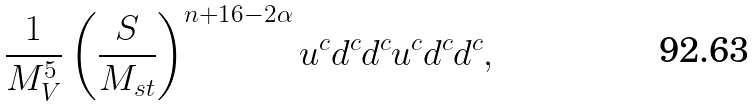Convert formula to latex. <formula><loc_0><loc_0><loc_500><loc_500>\frac { 1 } { M _ { V } ^ { 5 } } \left ( \frac { S } { M _ { s t } } \right ) ^ { n + 1 6 - 2 \alpha } u ^ { c } d ^ { c } d ^ { c } u ^ { c } d ^ { c } d ^ { c } ,</formula> 